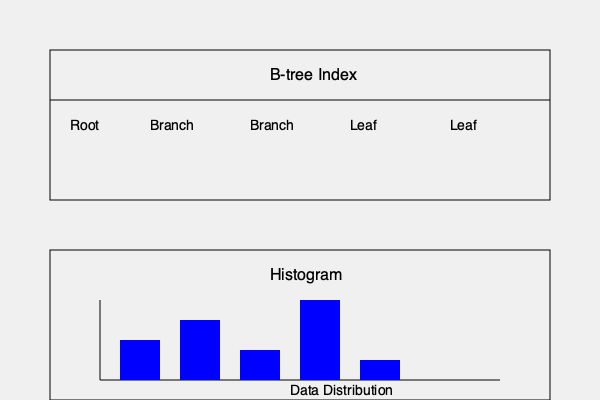For our e-commerce platform with millions of products, we need to optimize query performance on the product catalog. Given the diagram showing a B-tree index and a histogram, which indexing strategy would be most effective for querying products based on price, and why? To determine the most effective indexing strategy for querying products based on price, we need to consider the characteristics of B-tree indexes and histograms:

1. B-tree Index:
   - Efficiently handles equality and range queries
   - Maintains a balanced tree structure
   - Provides fast access for both small and large datasets
   - Works well for columns with high cardinality (many unique values)

2. Histogram:
   - Represents the distribution of data
   - Useful for estimating selectivity and query optimization
   - Helps in creating more accurate query plans

For querying products based on price in an e-commerce platform:

a) B-tree Index advantages:
   - Fast lookups for specific price points
   - Efficient for range queries (e.g., products between $50 and $100)
   - Supports sorting and ordered access

b) Histogram advantages:
   - Provides insights into price distribution
   - Helps optimize query plans for price ranges
   - Useful for statistics and data analysis

In this case, the B-tree index would be most effective for directly querying products based on price because:

1. It allows fast access to specific price points and ranges
2. It supports efficient sorting and ordered access, which is crucial for price-based queries
3. It scales well with large datasets, which is essential for millions of products

The histogram, while valuable for query optimization and understanding data distribution, is not an indexing strategy itself. However, it can be used in conjunction with the B-tree index to improve query performance:

1. Use the B-tree index as the primary indexing strategy for price-based queries
2. Utilize the histogram for query optimization and to guide the database optimizer in creating efficient query plans

By combining both approaches, we can achieve optimal query performance for our e-commerce platform's product catalog.
Answer: B-tree index, supplemented by histogram-based query optimization 